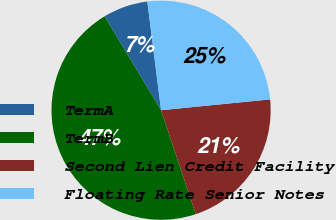<chart> <loc_0><loc_0><loc_500><loc_500><pie_chart><fcel>TermA<fcel>TermB<fcel>Second Lien Credit Facility<fcel>Floating Rate Senior Notes<nl><fcel>6.62%<fcel>46.51%<fcel>21.44%<fcel>25.43%<nl></chart> 